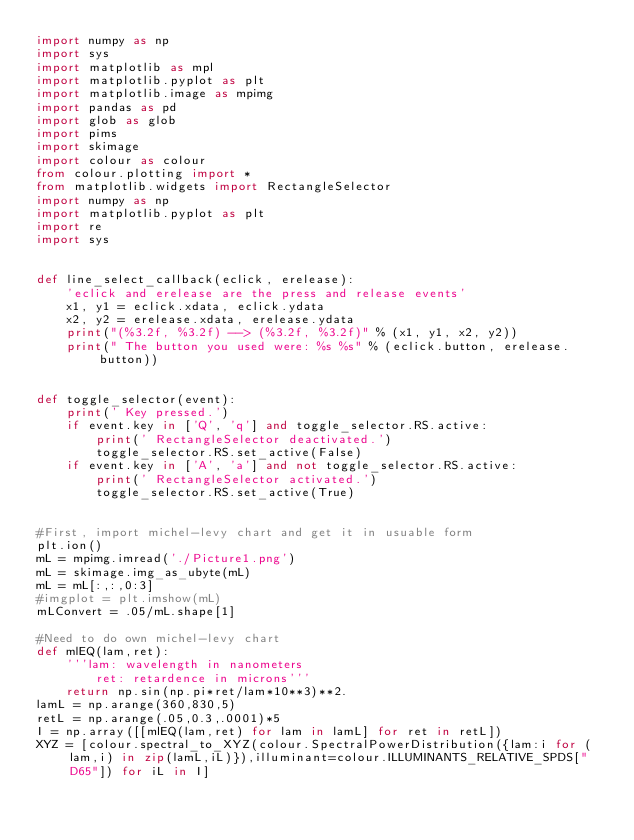<code> <loc_0><loc_0><loc_500><loc_500><_Python_>import numpy as np
import sys
import matplotlib as mpl
import matplotlib.pyplot as plt
import matplotlib.image as mpimg
import pandas as pd
import glob as glob
import pims
import skimage
import colour as colour
from colour.plotting import *
from matplotlib.widgets import RectangleSelector
import numpy as np
import matplotlib.pyplot as plt
import re
import sys


def line_select_callback(eclick, erelease):
    'eclick and erelease are the press and release events'
    x1, y1 = eclick.xdata, eclick.ydata
    x2, y2 = erelease.xdata, erelease.ydata
    print("(%3.2f, %3.2f) --> (%3.2f, %3.2f)" % (x1, y1, x2, y2))
    print(" The button you used were: %s %s" % (eclick.button, erelease.button))


def toggle_selector(event):
    print(' Key pressed.')
    if event.key in ['Q', 'q'] and toggle_selector.RS.active:
        print(' RectangleSelector deactivated.')
        toggle_selector.RS.set_active(False)
    if event.key in ['A', 'a'] and not toggle_selector.RS.active:
        print(' RectangleSelector activated.')
        toggle_selector.RS.set_active(True)


#First, import michel-levy chart and get it in usuable form
plt.ion()
mL = mpimg.imread('./Picture1.png')
mL = skimage.img_as_ubyte(mL)
mL = mL[:,:,0:3]
#imgplot = plt.imshow(mL)
mLConvert = .05/mL.shape[1]

#Need to do own michel-levy chart
def mlEQ(lam,ret):
    '''lam: wavelength in nanometers
        ret: retardence in microns'''
    return np.sin(np.pi*ret/lam*10**3)**2.
lamL = np.arange(360,830,5)
retL = np.arange(.05,0.3,.0001)*5
I = np.array([[mlEQ(lam,ret) for lam in lamL] for ret in retL])
XYZ = [colour.spectral_to_XYZ(colour.SpectralPowerDistribution({lam:i for (lam,i) in zip(lamL,iL)}),illuminant=colour.ILLUMINANTS_RELATIVE_SPDS["D65"]) for iL in I]</code> 